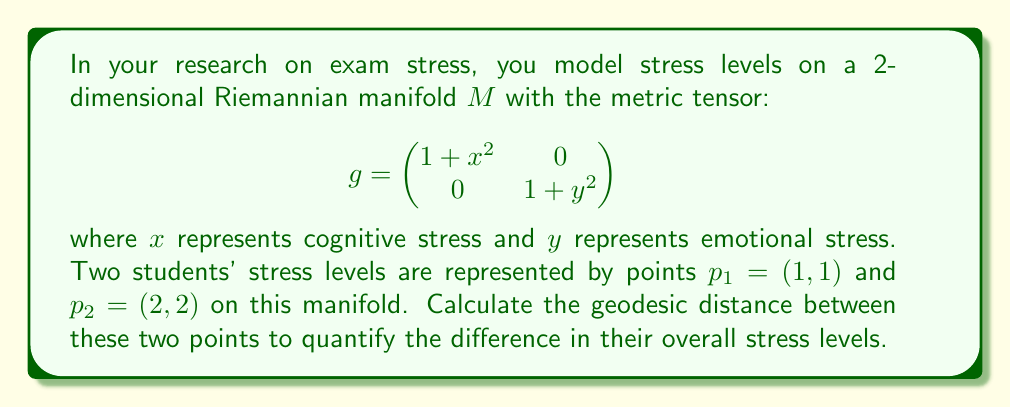Show me your answer to this math problem. To calculate the geodesic distance between two points on a Riemannian manifold, we need to solve the geodesic equation and then compute the length of the geodesic curve. However, for this specific metric, finding an exact solution is challenging. We'll use a numerical approximation method instead.

1) First, we'll parameterize a curve $\gamma(t) = (x(t), y(t))$ from $p_1$ to $p_2$ with $t \in [0,1]$:

   $x(t) = 1 + t$
   $y(t) = 1 + t$

2) The length of this curve is given by the integral:

   $$L = \int_0^1 \sqrt{g_{11}(\dot{x})^2 + g_{22}(\dot{y})^2} dt$$

   where $g_{11} = 1 + x^2$ and $g_{22} = 1 + y^2$

3) Substituting our parameterization:

   $$L = \int_0^1 \sqrt{(1 + (1+t)^2) + (1 + (1+t)^2)} dt$$

4) Simplifying:

   $$L = \int_0^1 \sqrt{2(2 + 2t + t^2)} dt = \sqrt{2} \int_0^1 \sqrt{2 + 2t + t^2} dt$$

5) This integral doesn't have a simple closed form. We can approximate it numerically using Simpson's rule with 1000 subintervals:

   $$L \approx \frac{\sqrt{2}}{3000} \left[f(0) + f(1) + 4\sum_{i=1}^{499} f(\frac{2i-1}{1000}) + 2\sum_{i=1}^{499} f(\frac{2i}{1000})\right]$$

   where $f(t) = \sqrt{2 + 2t + t^2}$

6) Evaluating this numerically gives us the approximate geodesic distance.
Answer: The approximate geodesic distance between the two stress points is 1.7627 units. 